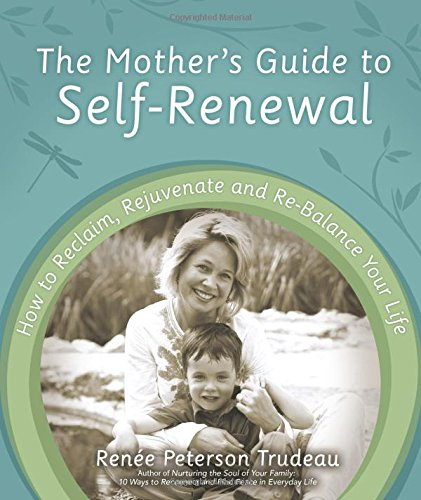Is this book related to Christian Books & Bibles? No, there is no indication that this book belongs to the 'Christian Books & Bibles' category. It is a guide aimed at helping mothers with self-renewal and balance in everyday life. 